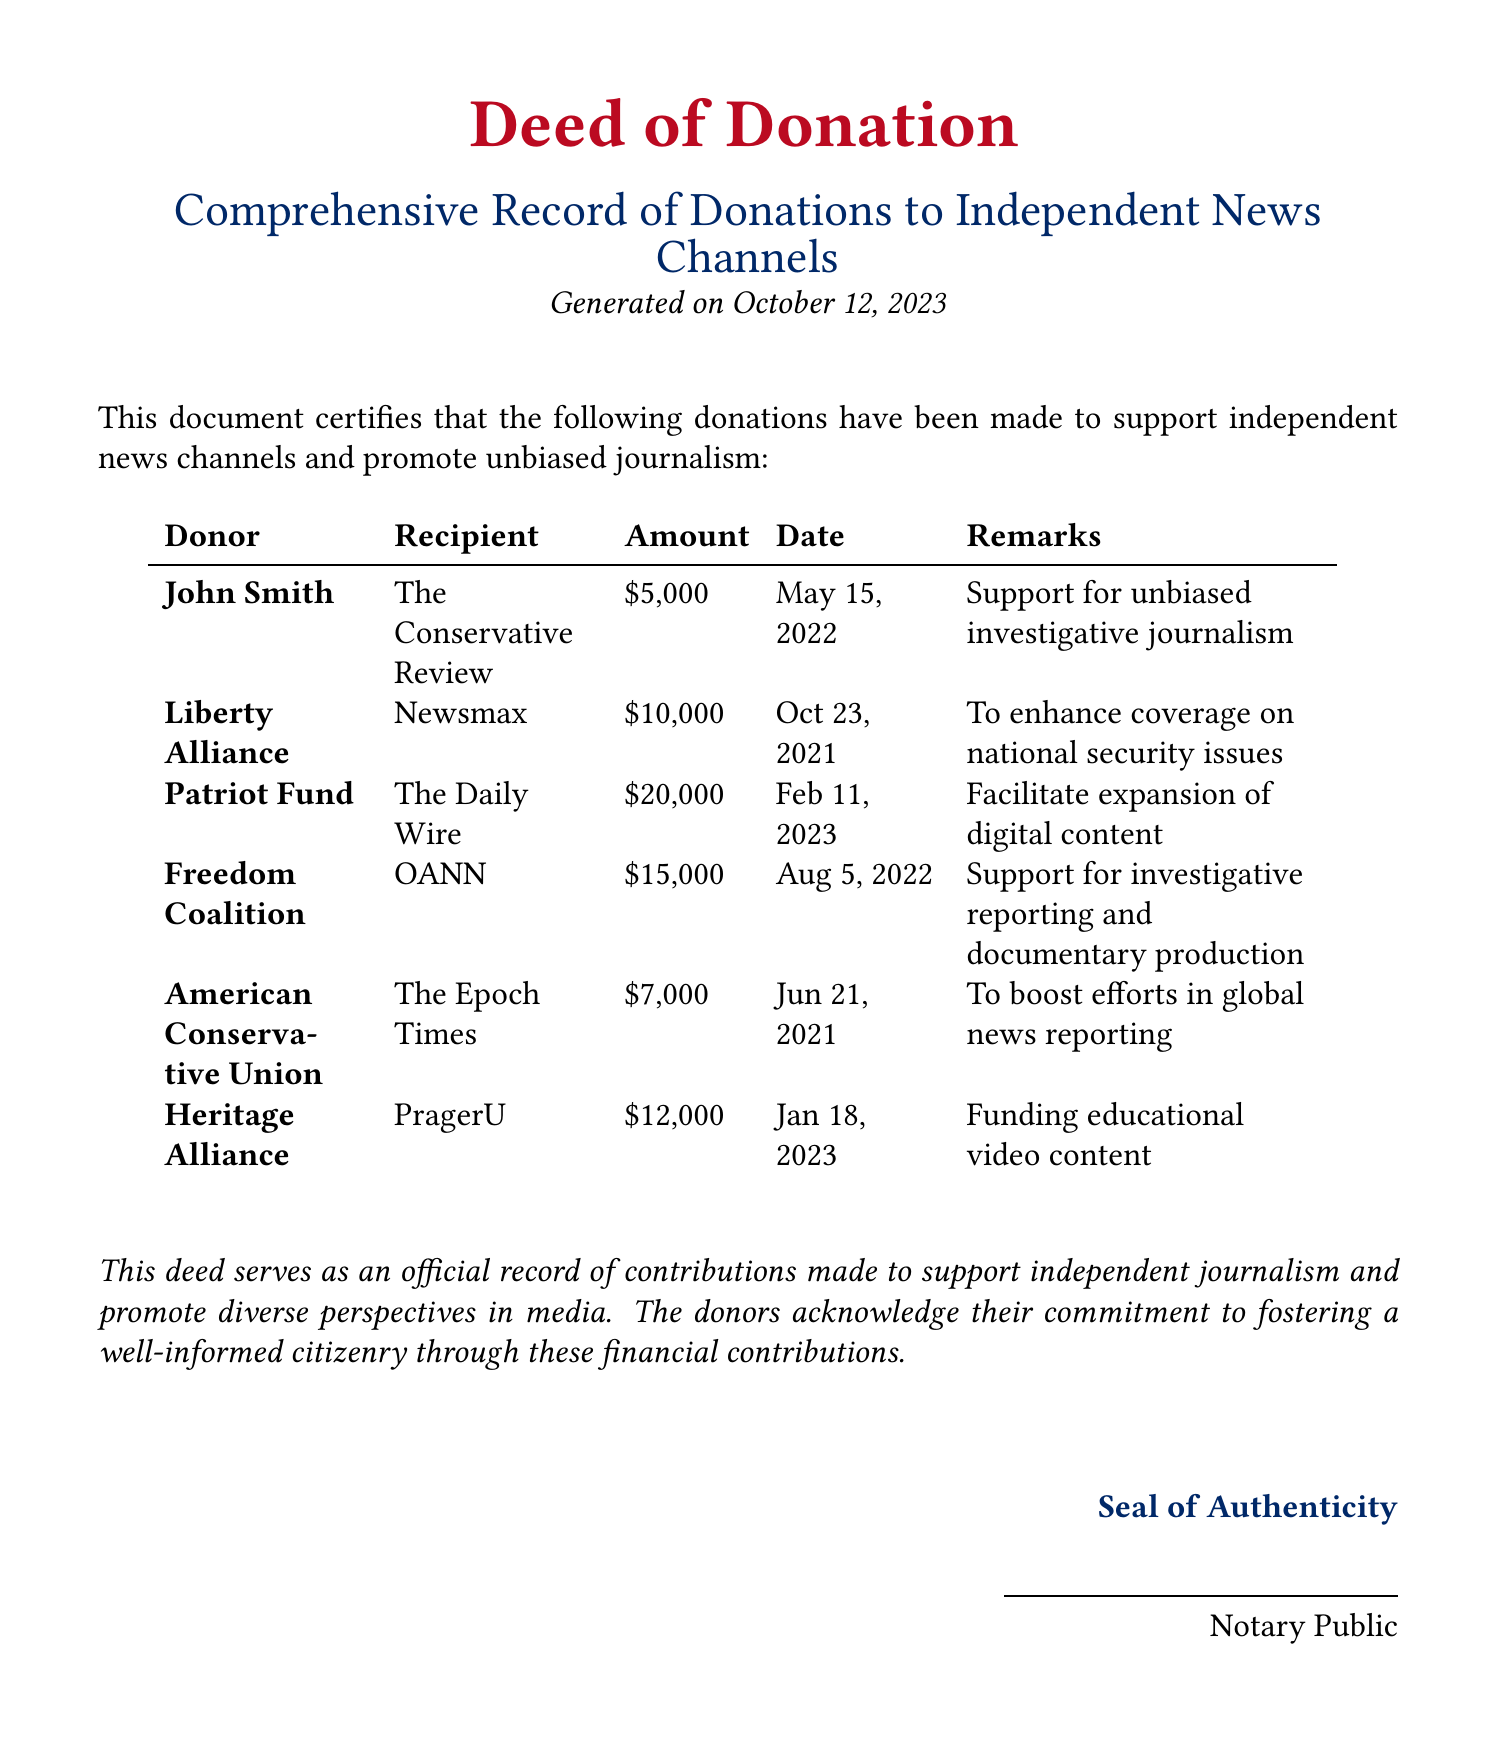What is the total amount donated to The Daily Wire? The total amount donated to The Daily Wire is the sum of all entries for that recipient, which is $20,000.
Answer: $20,000 Who is the donor of the largest donation listed? The largest donation listed is $20,000 which was made by Patriot Fund.
Answer: Patriot Fund What date was the donation to Newsmax made? The donation to Newsmax was made on October 23, 2021.
Answer: October 23, 2021 What recipient received a donation for educational content? The recipient that received a donation for educational content is PragerU.
Answer: PragerU How much did Freedom Coalition donate? Freedom Coalition donated $15,000 as specified in the document.
Answer: $15,000 Who confirmed the authenticity of this deed? The document indicates that a Notary Public confirmed its authenticity.
Answer: Notary Public How many donations were made to support OANN? There was one donation made to support OANN, which is listed in the document.
Answer: One What is the total number of unique recipients listed in the document? The document lists six unique recipients of the donations.
Answer: Six Which organization contributed to enhance coverage on national security issues? Liberty Alliance is the organization that contributed to enhance coverage on national security issues.
Answer: Liberty Alliance 